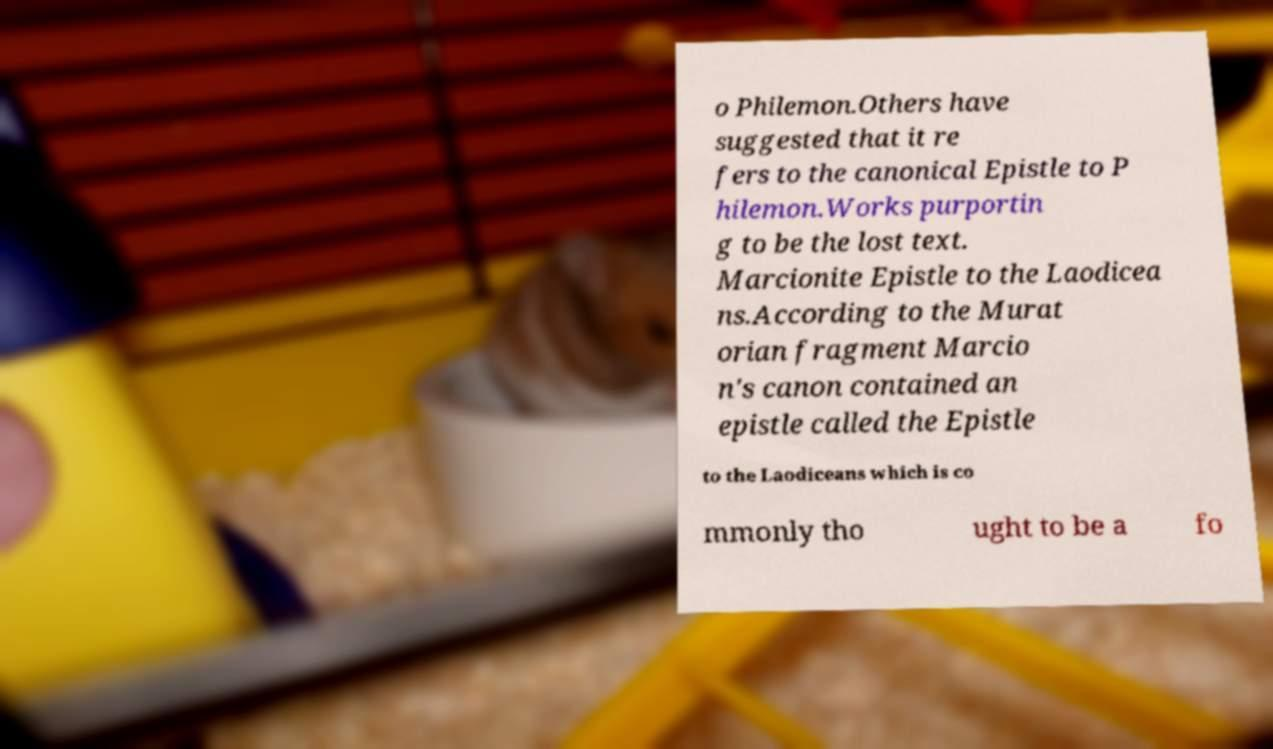Can you accurately transcribe the text from the provided image for me? o Philemon.Others have suggested that it re fers to the canonical Epistle to P hilemon.Works purportin g to be the lost text. Marcionite Epistle to the Laodicea ns.According to the Murat orian fragment Marcio n's canon contained an epistle called the Epistle to the Laodiceans which is co mmonly tho ught to be a fo 